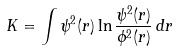Convert formula to latex. <formula><loc_0><loc_0><loc_500><loc_500>K = \int \psi ^ { 2 } ( r ) \ln { \frac { \psi ^ { 2 } ( r ) } { \phi ^ { 2 } ( r ) } } \, d r</formula> 